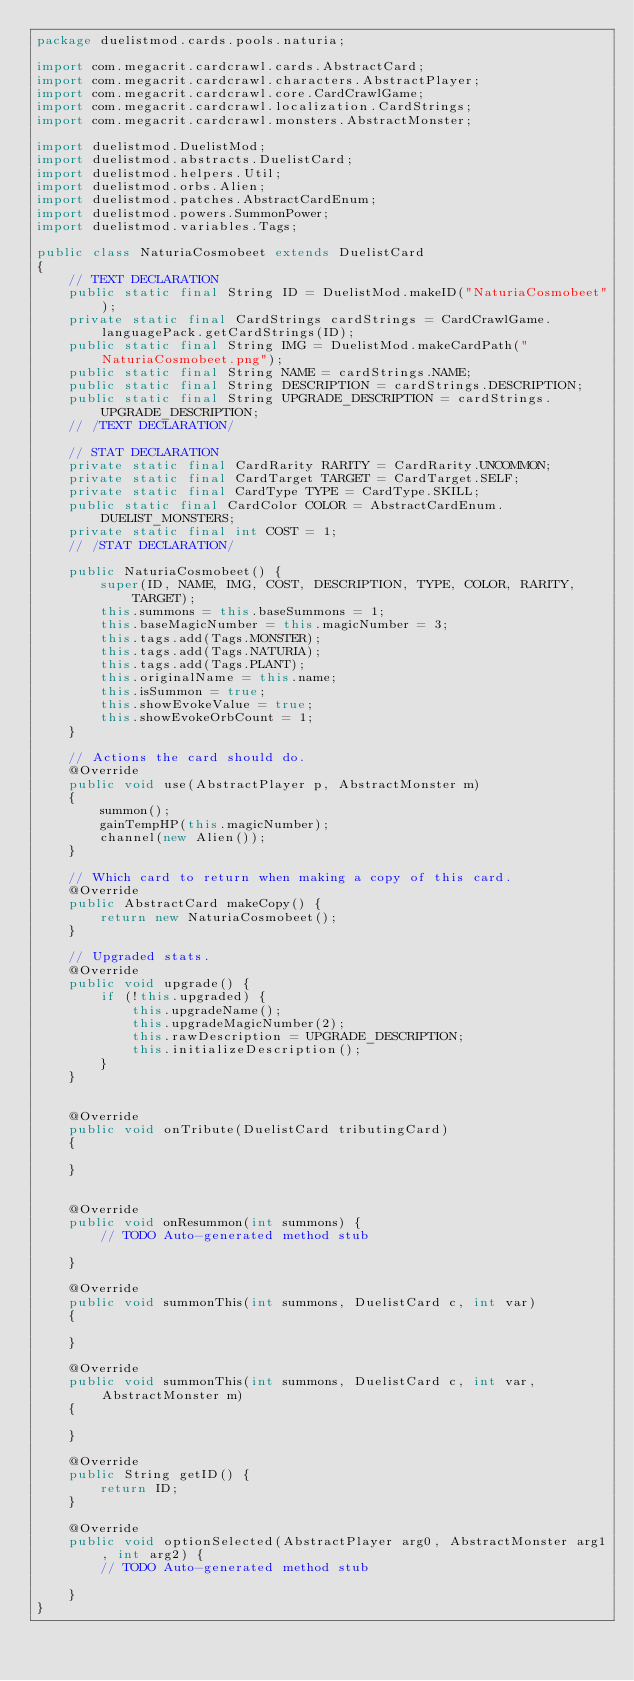Convert code to text. <code><loc_0><loc_0><loc_500><loc_500><_Java_>package duelistmod.cards.pools.naturia;

import com.megacrit.cardcrawl.cards.AbstractCard;
import com.megacrit.cardcrawl.characters.AbstractPlayer;
import com.megacrit.cardcrawl.core.CardCrawlGame;
import com.megacrit.cardcrawl.localization.CardStrings;
import com.megacrit.cardcrawl.monsters.AbstractMonster;

import duelistmod.DuelistMod;
import duelistmod.abstracts.DuelistCard;
import duelistmod.helpers.Util;
import duelistmod.orbs.Alien;
import duelistmod.patches.AbstractCardEnum;
import duelistmod.powers.SummonPower;
import duelistmod.variables.Tags;

public class NaturiaCosmobeet extends DuelistCard 
{
    // TEXT DECLARATION
    public static final String ID = DuelistMod.makeID("NaturiaCosmobeet");
    private static final CardStrings cardStrings = CardCrawlGame.languagePack.getCardStrings(ID);
    public static final String IMG = DuelistMod.makeCardPath("NaturiaCosmobeet.png");
    public static final String NAME = cardStrings.NAME;
    public static final String DESCRIPTION = cardStrings.DESCRIPTION;
    public static final String UPGRADE_DESCRIPTION = cardStrings.UPGRADE_DESCRIPTION;
    // /TEXT DECLARATION/

    // STAT DECLARATION
    private static final CardRarity RARITY = CardRarity.UNCOMMON;
    private static final CardTarget TARGET = CardTarget.SELF;
    private static final CardType TYPE = CardType.SKILL;
    public static final CardColor COLOR = AbstractCardEnum.DUELIST_MONSTERS;
    private static final int COST = 1;
    // /STAT DECLARATION/

    public NaturiaCosmobeet() {
        super(ID, NAME, IMG, COST, DESCRIPTION, TYPE, COLOR, RARITY, TARGET);
        this.summons = this.baseSummons = 1;
        this.baseMagicNumber = this.magicNumber = 3;
        this.tags.add(Tags.MONSTER);
        this.tags.add(Tags.NATURIA);
        this.tags.add(Tags.PLANT);
        this.originalName = this.name;
        this.isSummon = true;
		this.showEvokeValue = true;
		this.showEvokeOrbCount = 1;
    }

    // Actions the card should do.
    @Override
    public void use(AbstractPlayer p, AbstractMonster m) 
    {
    	summon();
    	gainTempHP(this.magicNumber);
    	channel(new Alien());
    }

    // Which card to return when making a copy of this card.
    @Override
    public AbstractCard makeCopy() {
        return new NaturiaCosmobeet();
    }

    // Upgraded stats.
    @Override
    public void upgrade() {
        if (!this.upgraded) {
            this.upgradeName();
            this.upgradeMagicNumber(2);
            this.rawDescription = UPGRADE_DESCRIPTION;
            this.initializeDescription();
        }
    }


	@Override
	public void onTribute(DuelistCard tributingCard) 
	{
		
	}


	@Override
	public void onResummon(int summons) {
		// TODO Auto-generated method stub
		
	}

	@Override
	public void summonThis(int summons, DuelistCard c, int var) 
	{

	}

	@Override
	public void summonThis(int summons, DuelistCard c, int var, AbstractMonster m) 
	{
	
	}

	@Override
	public String getID() {
		return ID;
	}

	@Override
	public void optionSelected(AbstractPlayer arg0, AbstractMonster arg1, int arg2) {
		// TODO Auto-generated method stub
		
	}
}
</code> 